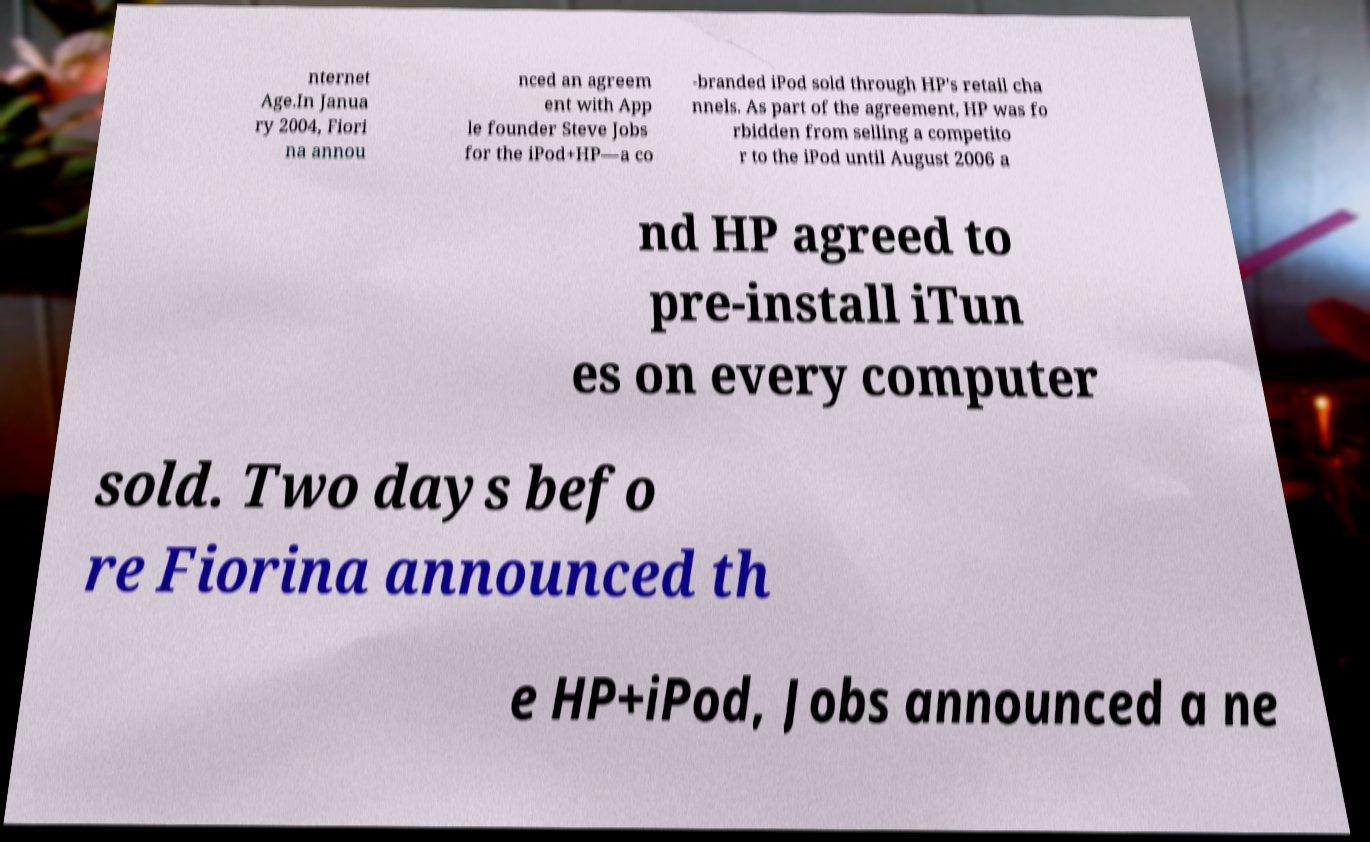Could you extract and type out the text from this image? nternet Age.In Janua ry 2004, Fiori na annou nced an agreem ent with App le founder Steve Jobs for the iPod+HP—a co -branded iPod sold through HP's retail cha nnels. As part of the agreement, HP was fo rbidden from selling a competito r to the iPod until August 2006 a nd HP agreed to pre-install iTun es on every computer sold. Two days befo re Fiorina announced th e HP+iPod, Jobs announced a ne 